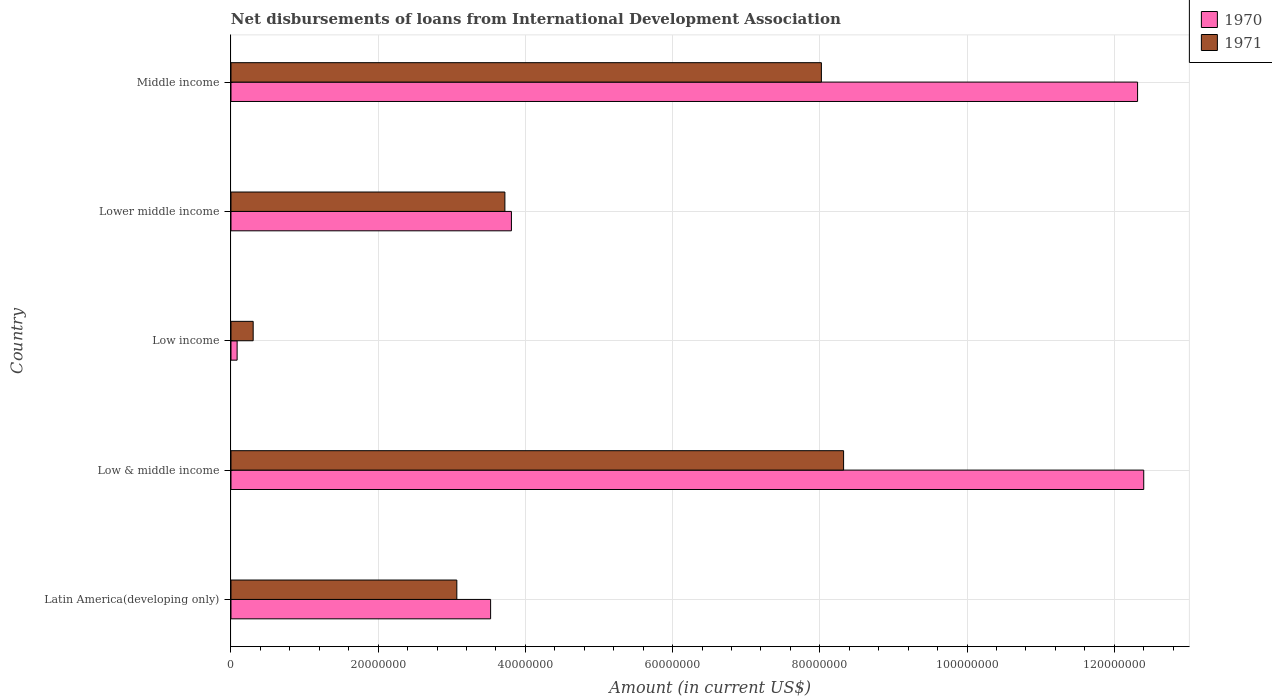Are the number of bars on each tick of the Y-axis equal?
Give a very brief answer. Yes. How many bars are there on the 4th tick from the bottom?
Your answer should be compact. 2. What is the label of the 5th group of bars from the top?
Provide a succinct answer. Latin America(developing only). What is the amount of loans disbursed in 1970 in Middle income?
Make the answer very short. 1.23e+08. Across all countries, what is the maximum amount of loans disbursed in 1970?
Provide a short and direct response. 1.24e+08. Across all countries, what is the minimum amount of loans disbursed in 1971?
Your answer should be compact. 3.02e+06. In which country was the amount of loans disbursed in 1971 maximum?
Provide a short and direct response. Low & middle income. In which country was the amount of loans disbursed in 1970 minimum?
Your answer should be compact. Low income. What is the total amount of loans disbursed in 1971 in the graph?
Your answer should be very brief. 2.34e+08. What is the difference between the amount of loans disbursed in 1970 in Low income and that in Middle income?
Keep it short and to the point. -1.22e+08. What is the difference between the amount of loans disbursed in 1970 in Lower middle income and the amount of loans disbursed in 1971 in Latin America(developing only)?
Give a very brief answer. 7.42e+06. What is the average amount of loans disbursed in 1970 per country?
Provide a short and direct response. 6.43e+07. What is the difference between the amount of loans disbursed in 1971 and amount of loans disbursed in 1970 in Low & middle income?
Ensure brevity in your answer.  -4.08e+07. In how many countries, is the amount of loans disbursed in 1970 greater than 4000000 US$?
Keep it short and to the point. 4. What is the ratio of the amount of loans disbursed in 1970 in Lower middle income to that in Middle income?
Your answer should be compact. 0.31. What is the difference between the highest and the second highest amount of loans disbursed in 1970?
Offer a terse response. 8.35e+05. What is the difference between the highest and the lowest amount of loans disbursed in 1971?
Offer a terse response. 8.02e+07. In how many countries, is the amount of loans disbursed in 1970 greater than the average amount of loans disbursed in 1970 taken over all countries?
Your answer should be compact. 2. Is the sum of the amount of loans disbursed in 1970 in Low income and Middle income greater than the maximum amount of loans disbursed in 1971 across all countries?
Offer a very short reply. Yes. What does the 2nd bar from the top in Low income represents?
Your answer should be very brief. 1970. Are all the bars in the graph horizontal?
Offer a very short reply. Yes. How many countries are there in the graph?
Give a very brief answer. 5. Are the values on the major ticks of X-axis written in scientific E-notation?
Offer a very short reply. No. How are the legend labels stacked?
Provide a succinct answer. Vertical. What is the title of the graph?
Offer a very short reply. Net disbursements of loans from International Development Association. What is the Amount (in current US$) of 1970 in Latin America(developing only)?
Keep it short and to the point. 3.53e+07. What is the Amount (in current US$) of 1971 in Latin America(developing only)?
Your response must be concise. 3.07e+07. What is the Amount (in current US$) of 1970 in Low & middle income?
Provide a short and direct response. 1.24e+08. What is the Amount (in current US$) of 1971 in Low & middle income?
Ensure brevity in your answer.  8.32e+07. What is the Amount (in current US$) of 1970 in Low income?
Your response must be concise. 8.35e+05. What is the Amount (in current US$) in 1971 in Low income?
Ensure brevity in your answer.  3.02e+06. What is the Amount (in current US$) of 1970 in Lower middle income?
Your answer should be compact. 3.81e+07. What is the Amount (in current US$) of 1971 in Lower middle income?
Offer a very short reply. 3.72e+07. What is the Amount (in current US$) of 1970 in Middle income?
Provide a short and direct response. 1.23e+08. What is the Amount (in current US$) of 1971 in Middle income?
Your answer should be compact. 8.02e+07. Across all countries, what is the maximum Amount (in current US$) of 1970?
Give a very brief answer. 1.24e+08. Across all countries, what is the maximum Amount (in current US$) of 1971?
Offer a terse response. 8.32e+07. Across all countries, what is the minimum Amount (in current US$) in 1970?
Offer a very short reply. 8.35e+05. Across all countries, what is the minimum Amount (in current US$) of 1971?
Offer a very short reply. 3.02e+06. What is the total Amount (in current US$) of 1970 in the graph?
Provide a succinct answer. 3.21e+08. What is the total Amount (in current US$) in 1971 in the graph?
Offer a terse response. 2.34e+08. What is the difference between the Amount (in current US$) of 1970 in Latin America(developing only) and that in Low & middle income?
Offer a very short reply. -8.87e+07. What is the difference between the Amount (in current US$) in 1971 in Latin America(developing only) and that in Low & middle income?
Provide a short and direct response. -5.25e+07. What is the difference between the Amount (in current US$) of 1970 in Latin America(developing only) and that in Low income?
Give a very brief answer. 3.44e+07. What is the difference between the Amount (in current US$) of 1971 in Latin America(developing only) and that in Low income?
Your response must be concise. 2.77e+07. What is the difference between the Amount (in current US$) in 1970 in Latin America(developing only) and that in Lower middle income?
Keep it short and to the point. -2.83e+06. What is the difference between the Amount (in current US$) of 1971 in Latin America(developing only) and that in Lower middle income?
Provide a short and direct response. -6.53e+06. What is the difference between the Amount (in current US$) in 1970 in Latin America(developing only) and that in Middle income?
Your response must be concise. -8.79e+07. What is the difference between the Amount (in current US$) in 1971 in Latin America(developing only) and that in Middle income?
Your response must be concise. -4.95e+07. What is the difference between the Amount (in current US$) in 1970 in Low & middle income and that in Low income?
Offer a very short reply. 1.23e+08. What is the difference between the Amount (in current US$) of 1971 in Low & middle income and that in Low income?
Provide a succinct answer. 8.02e+07. What is the difference between the Amount (in current US$) of 1970 in Low & middle income and that in Lower middle income?
Offer a very short reply. 8.59e+07. What is the difference between the Amount (in current US$) in 1971 in Low & middle income and that in Lower middle income?
Your response must be concise. 4.60e+07. What is the difference between the Amount (in current US$) in 1970 in Low & middle income and that in Middle income?
Offer a terse response. 8.35e+05. What is the difference between the Amount (in current US$) of 1971 in Low & middle income and that in Middle income?
Offer a very short reply. 3.02e+06. What is the difference between the Amount (in current US$) in 1970 in Low income and that in Lower middle income?
Make the answer very short. -3.73e+07. What is the difference between the Amount (in current US$) in 1971 in Low income and that in Lower middle income?
Offer a terse response. -3.42e+07. What is the difference between the Amount (in current US$) of 1970 in Low income and that in Middle income?
Offer a terse response. -1.22e+08. What is the difference between the Amount (in current US$) of 1971 in Low income and that in Middle income?
Your response must be concise. -7.72e+07. What is the difference between the Amount (in current US$) in 1970 in Lower middle income and that in Middle income?
Make the answer very short. -8.51e+07. What is the difference between the Amount (in current US$) of 1971 in Lower middle income and that in Middle income?
Give a very brief answer. -4.30e+07. What is the difference between the Amount (in current US$) of 1970 in Latin America(developing only) and the Amount (in current US$) of 1971 in Low & middle income?
Ensure brevity in your answer.  -4.80e+07. What is the difference between the Amount (in current US$) in 1970 in Latin America(developing only) and the Amount (in current US$) in 1971 in Low income?
Your answer should be very brief. 3.23e+07. What is the difference between the Amount (in current US$) in 1970 in Latin America(developing only) and the Amount (in current US$) in 1971 in Lower middle income?
Keep it short and to the point. -1.94e+06. What is the difference between the Amount (in current US$) of 1970 in Latin America(developing only) and the Amount (in current US$) of 1971 in Middle income?
Offer a terse response. -4.49e+07. What is the difference between the Amount (in current US$) in 1970 in Low & middle income and the Amount (in current US$) in 1971 in Low income?
Keep it short and to the point. 1.21e+08. What is the difference between the Amount (in current US$) in 1970 in Low & middle income and the Amount (in current US$) in 1971 in Lower middle income?
Your answer should be compact. 8.68e+07. What is the difference between the Amount (in current US$) of 1970 in Low & middle income and the Amount (in current US$) of 1971 in Middle income?
Your answer should be compact. 4.38e+07. What is the difference between the Amount (in current US$) in 1970 in Low income and the Amount (in current US$) in 1971 in Lower middle income?
Offer a terse response. -3.64e+07. What is the difference between the Amount (in current US$) in 1970 in Low income and the Amount (in current US$) in 1971 in Middle income?
Your answer should be very brief. -7.94e+07. What is the difference between the Amount (in current US$) of 1970 in Lower middle income and the Amount (in current US$) of 1971 in Middle income?
Ensure brevity in your answer.  -4.21e+07. What is the average Amount (in current US$) of 1970 per country?
Give a very brief answer. 6.43e+07. What is the average Amount (in current US$) of 1971 per country?
Your answer should be very brief. 4.69e+07. What is the difference between the Amount (in current US$) of 1970 and Amount (in current US$) of 1971 in Latin America(developing only)?
Your response must be concise. 4.59e+06. What is the difference between the Amount (in current US$) of 1970 and Amount (in current US$) of 1971 in Low & middle income?
Provide a succinct answer. 4.08e+07. What is the difference between the Amount (in current US$) in 1970 and Amount (in current US$) in 1971 in Low income?
Offer a terse response. -2.18e+06. What is the difference between the Amount (in current US$) of 1970 and Amount (in current US$) of 1971 in Lower middle income?
Offer a terse response. 8.88e+05. What is the difference between the Amount (in current US$) in 1970 and Amount (in current US$) in 1971 in Middle income?
Make the answer very short. 4.30e+07. What is the ratio of the Amount (in current US$) of 1970 in Latin America(developing only) to that in Low & middle income?
Make the answer very short. 0.28. What is the ratio of the Amount (in current US$) of 1971 in Latin America(developing only) to that in Low & middle income?
Provide a succinct answer. 0.37. What is the ratio of the Amount (in current US$) of 1970 in Latin America(developing only) to that in Low income?
Keep it short and to the point. 42.24. What is the ratio of the Amount (in current US$) of 1971 in Latin America(developing only) to that in Low income?
Your answer should be compact. 10.17. What is the ratio of the Amount (in current US$) in 1970 in Latin America(developing only) to that in Lower middle income?
Provide a succinct answer. 0.93. What is the ratio of the Amount (in current US$) in 1971 in Latin America(developing only) to that in Lower middle income?
Keep it short and to the point. 0.82. What is the ratio of the Amount (in current US$) in 1970 in Latin America(developing only) to that in Middle income?
Offer a terse response. 0.29. What is the ratio of the Amount (in current US$) in 1971 in Latin America(developing only) to that in Middle income?
Provide a short and direct response. 0.38. What is the ratio of the Amount (in current US$) of 1970 in Low & middle income to that in Low income?
Offer a terse response. 148.5. What is the ratio of the Amount (in current US$) of 1971 in Low & middle income to that in Low income?
Your answer should be compact. 27.59. What is the ratio of the Amount (in current US$) in 1970 in Low & middle income to that in Lower middle income?
Keep it short and to the point. 3.25. What is the ratio of the Amount (in current US$) in 1971 in Low & middle income to that in Lower middle income?
Offer a terse response. 2.24. What is the ratio of the Amount (in current US$) in 1970 in Low & middle income to that in Middle income?
Give a very brief answer. 1.01. What is the ratio of the Amount (in current US$) of 1971 in Low & middle income to that in Middle income?
Give a very brief answer. 1.04. What is the ratio of the Amount (in current US$) of 1970 in Low income to that in Lower middle income?
Offer a terse response. 0.02. What is the ratio of the Amount (in current US$) in 1971 in Low income to that in Lower middle income?
Your answer should be compact. 0.08. What is the ratio of the Amount (in current US$) in 1970 in Low income to that in Middle income?
Offer a terse response. 0.01. What is the ratio of the Amount (in current US$) in 1971 in Low income to that in Middle income?
Keep it short and to the point. 0.04. What is the ratio of the Amount (in current US$) in 1970 in Lower middle income to that in Middle income?
Provide a succinct answer. 0.31. What is the ratio of the Amount (in current US$) in 1971 in Lower middle income to that in Middle income?
Give a very brief answer. 0.46. What is the difference between the highest and the second highest Amount (in current US$) in 1970?
Keep it short and to the point. 8.35e+05. What is the difference between the highest and the second highest Amount (in current US$) of 1971?
Your answer should be very brief. 3.02e+06. What is the difference between the highest and the lowest Amount (in current US$) of 1970?
Keep it short and to the point. 1.23e+08. What is the difference between the highest and the lowest Amount (in current US$) in 1971?
Offer a very short reply. 8.02e+07. 